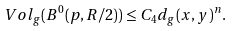<formula> <loc_0><loc_0><loc_500><loc_500>V o l _ { g } ( B ^ { 0 } ( p , R / 2 ) ) \leq C _ { 4 } d _ { g } ( x , y ) ^ { n } .</formula> 